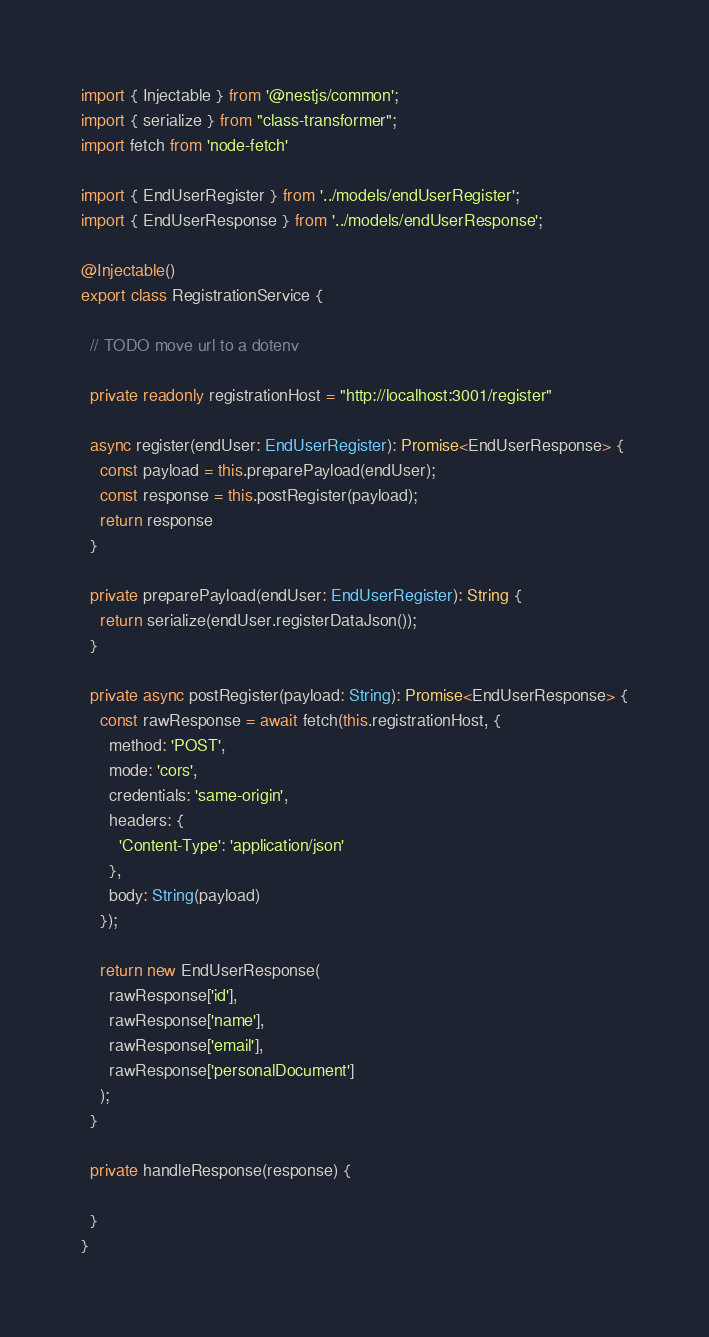Convert code to text. <code><loc_0><loc_0><loc_500><loc_500><_TypeScript_>import { Injectable } from '@nestjs/common';
import { serialize } from "class-transformer";
import fetch from 'node-fetch'

import { EndUserRegister } from '../models/endUserRegister';
import { EndUserResponse } from '../models/endUserResponse';

@Injectable()
export class RegistrationService {

  // TODO move url to a dotenv

  private readonly registrationHost = "http://localhost:3001/register"

  async register(endUser: EndUserRegister): Promise<EndUserResponse> {
    const payload = this.preparePayload(endUser);
    const response = this.postRegister(payload);
    return response
  }

  private preparePayload(endUser: EndUserRegister): String {
    return serialize(endUser.registerDataJson());
  }

  private async postRegister(payload: String): Promise<EndUserResponse> {
    const rawResponse = await fetch(this.registrationHost, {
      method: 'POST',
      mode: 'cors',
      credentials: 'same-origin',
      headers: {
        'Content-Type': 'application/json'
      },
      body: String(payload)
    });

    return new EndUserResponse(
      rawResponse['id'],
      rawResponse['name'],
      rawResponse['email'],
      rawResponse['personalDocument']
    );
  }

  private handleResponse(response) {

  }
}
</code> 